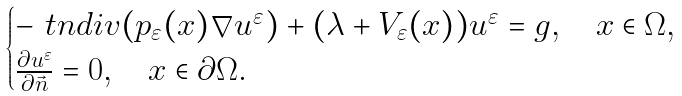<formula> <loc_0><loc_0><loc_500><loc_500>\begin{cases} - \ t n { d i v } ( p _ { \varepsilon } ( x ) \nabla u ^ { \varepsilon } ) + ( \lambda + V _ { \varepsilon } ( x ) ) u ^ { \varepsilon } = g , \quad x \in \Omega , \\ \frac { \partial u ^ { \varepsilon } } { \partial \vec { n } } = 0 , \quad x \in \partial \Omega . \end{cases}</formula> 